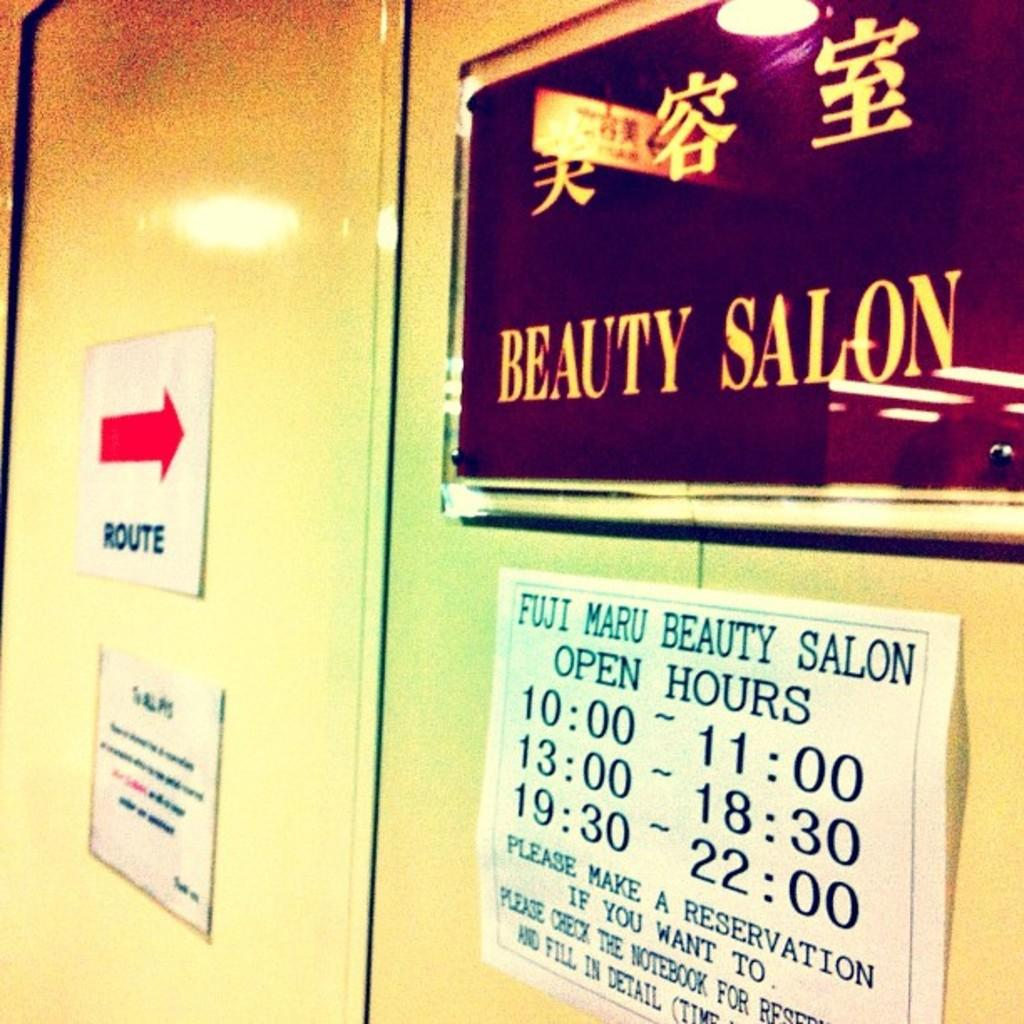<image>
Give a short and clear explanation of the subsequent image. A white sign that displays the hours of operation for the Fuji Maru Beauty Salon. 